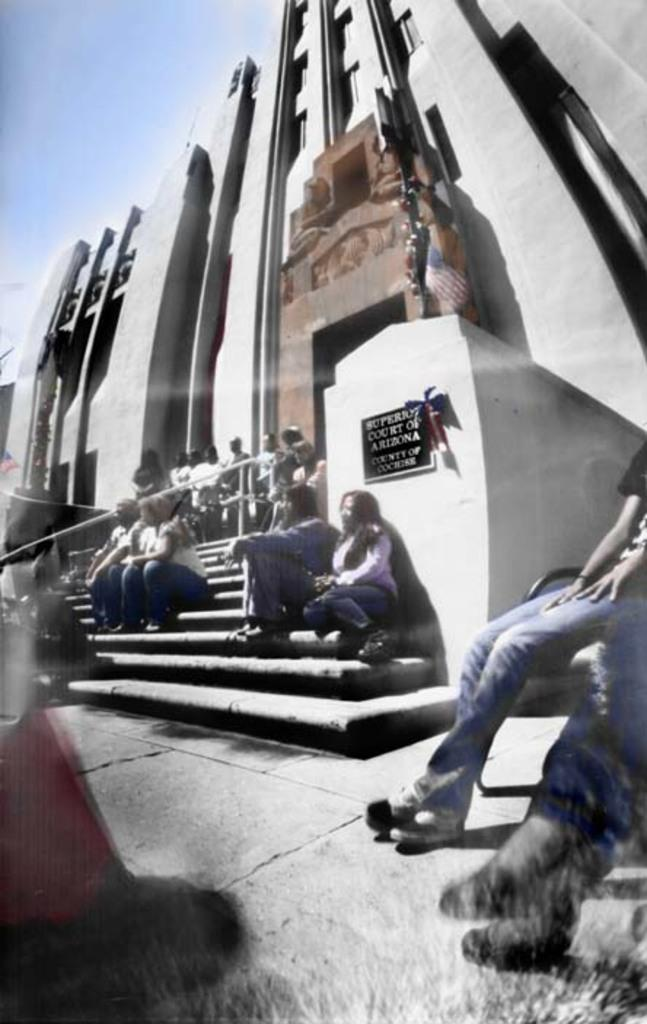What are the people in the image doing? There are people sitting on the stairs and people standing near a building in the image. Can you describe the location of the people in the image? The people sitting on the stairs are on the stairs, while the people standing near a building are near a building. What type of powder can be seen falling from the sky in the image? There is no powder falling from the sky in the image. What is the people's reaction to the string in the image? There is no string present in the image. 